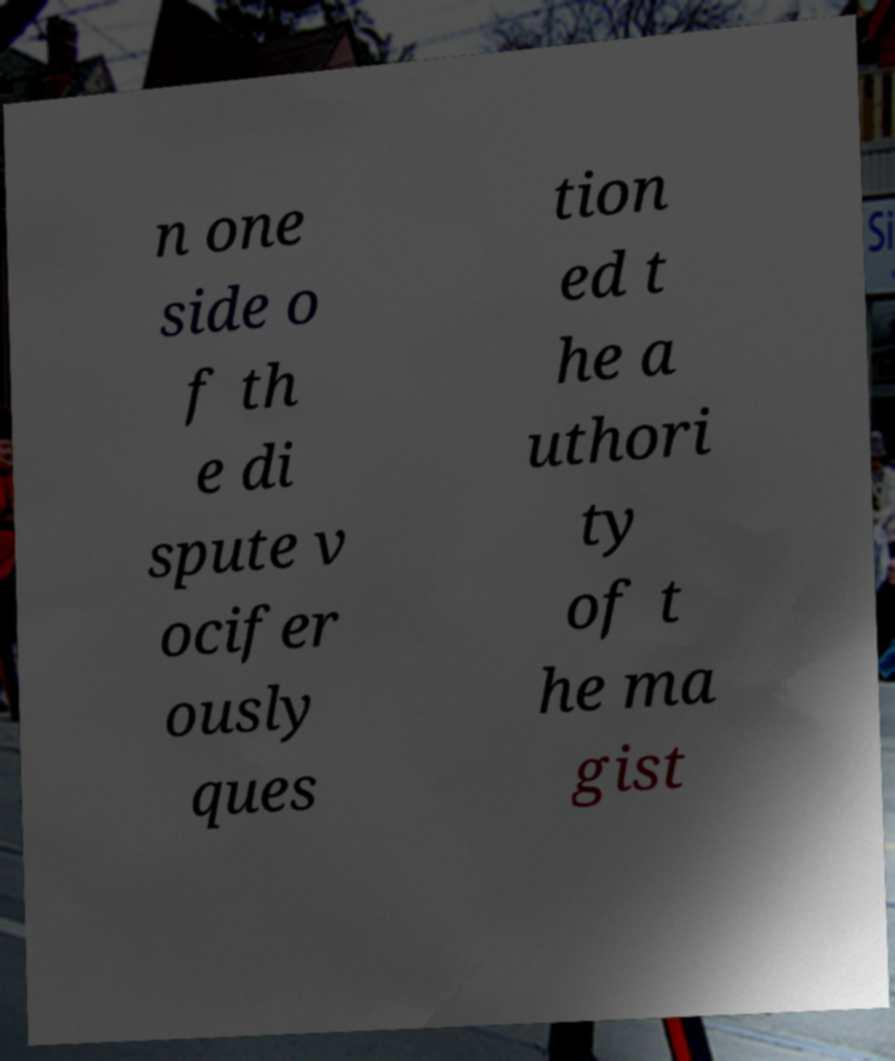I need the written content from this picture converted into text. Can you do that? n one side o f th e di spute v ocifer ously ques tion ed t he a uthori ty of t he ma gist 